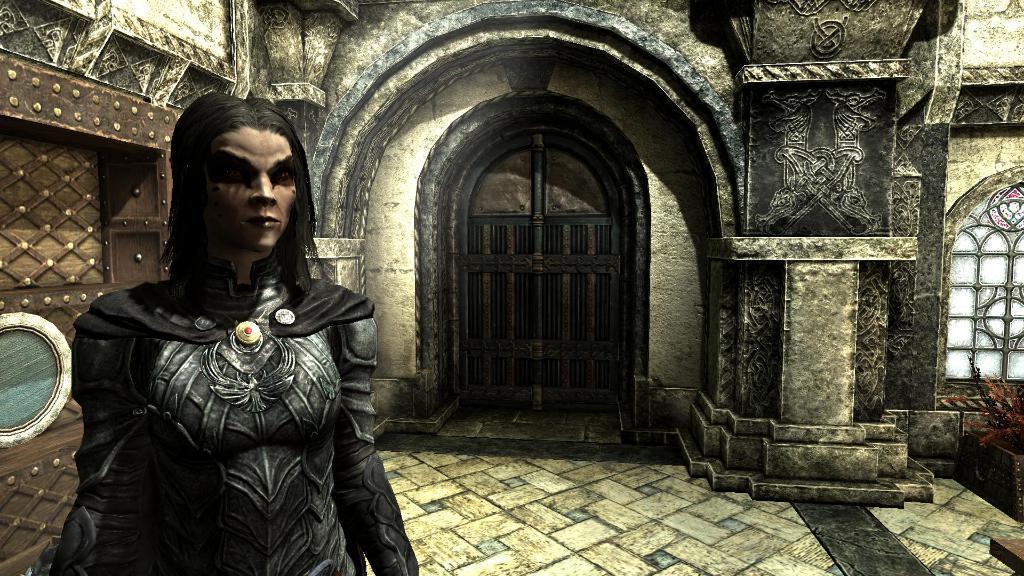Could you give a brief overview of what you see in this image? In the foreground of this animated image, on the left, there is a person standing. In the background, there is a building, an arch, floor and the window. 